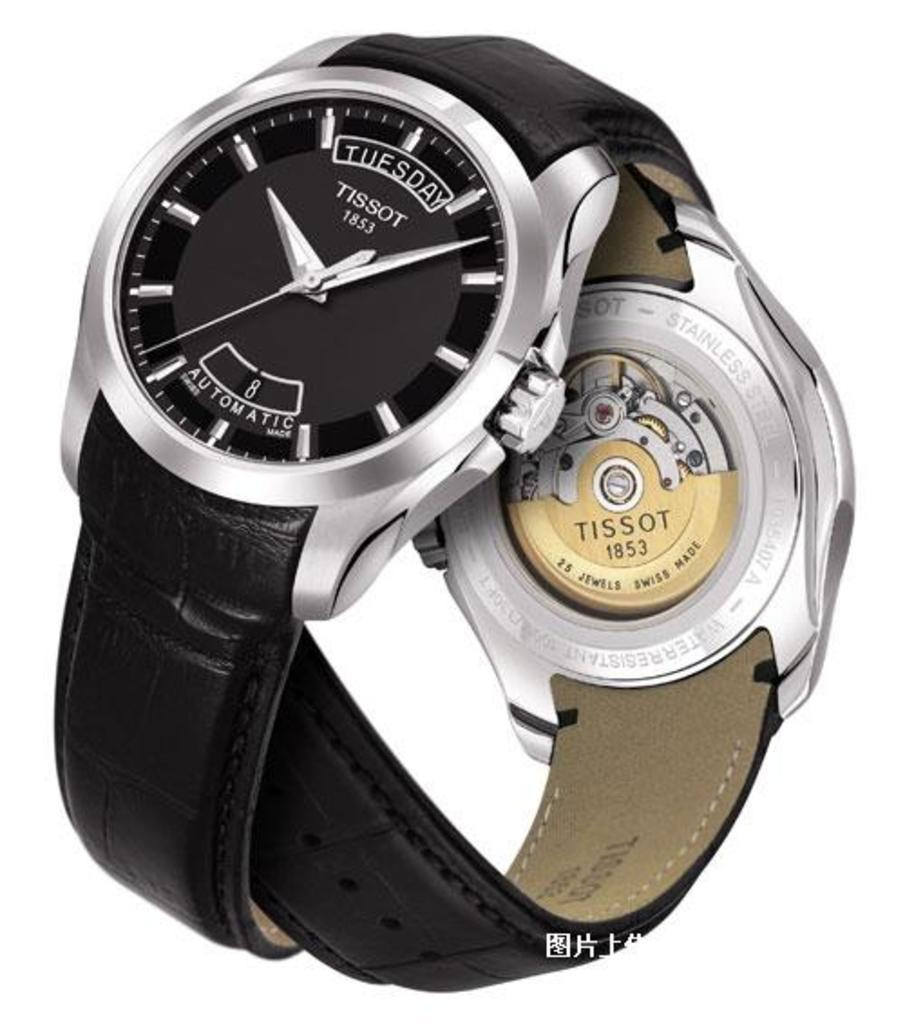<image>
Render a clear and concise summary of the photo. Two Tissot 1853 watches are entwined together in this ad. 